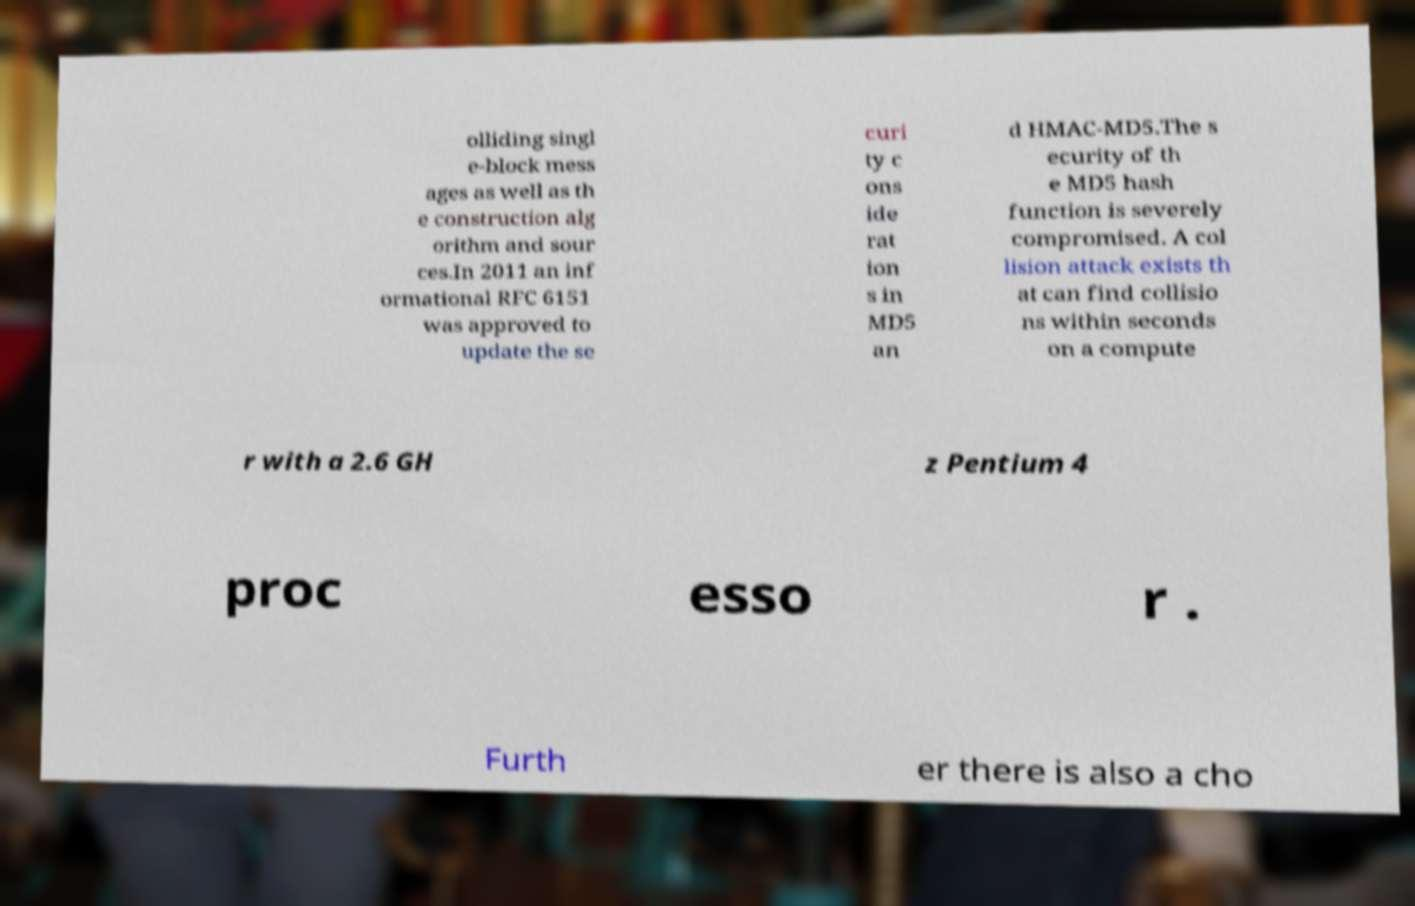Can you accurately transcribe the text from the provided image for me? olliding singl e-block mess ages as well as th e construction alg orithm and sour ces.In 2011 an inf ormational RFC 6151 was approved to update the se curi ty c ons ide rat ion s in MD5 an d HMAC-MD5.The s ecurity of th e MD5 hash function is severely compromised. A col lision attack exists th at can find collisio ns within seconds on a compute r with a 2.6 GH z Pentium 4 proc esso r . Furth er there is also a cho 